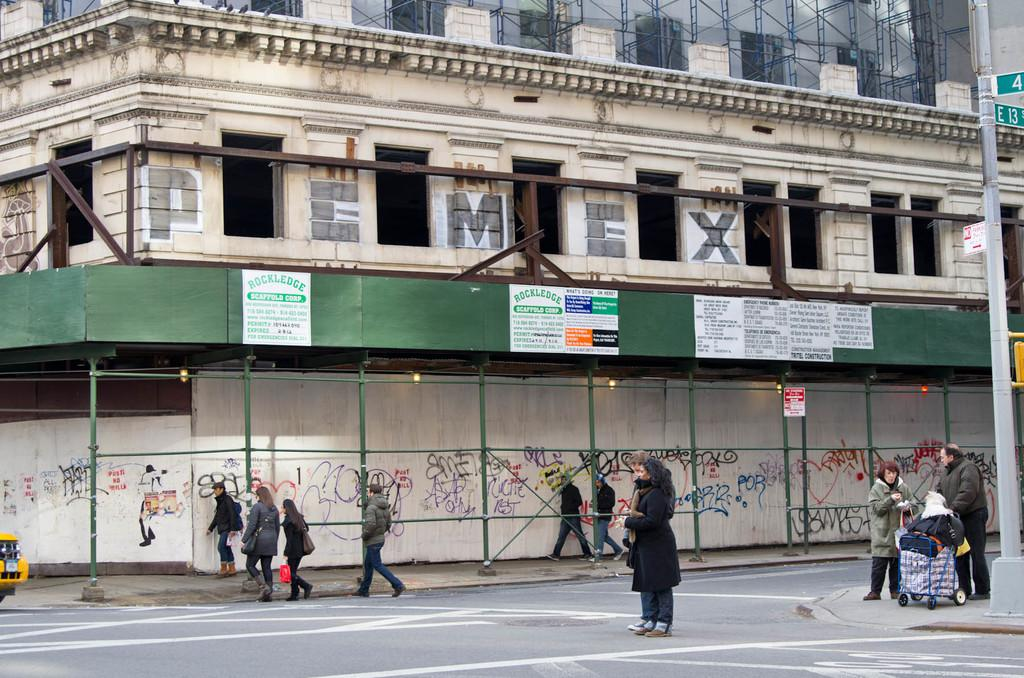<image>
Write a terse but informative summary of the picture. A building with people walking around with advertisement that says Rock Ledge. 